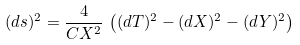<formula> <loc_0><loc_0><loc_500><loc_500>( d s ) ^ { 2 } = \frac { 4 } { C X ^ { 2 } } \, \left ( ( d T ) ^ { 2 } - ( d X ) ^ { 2 } - ( d Y ) ^ { 2 } \right )</formula> 